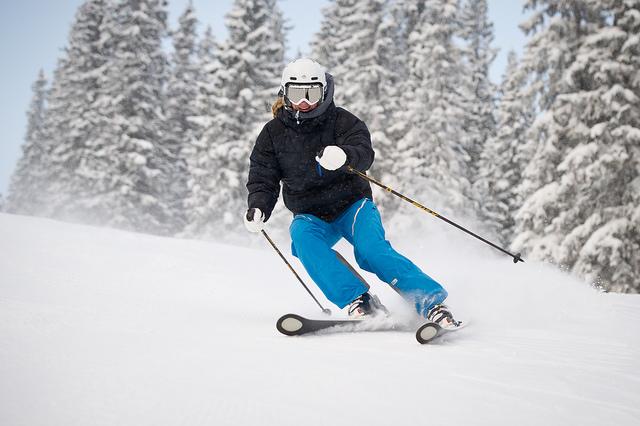What color are the persons pants?
Concise answer only. Blue. Is the man wearing glasses?
Give a very brief answer. Yes. Has this person skied before?
Concise answer only. Yes. 